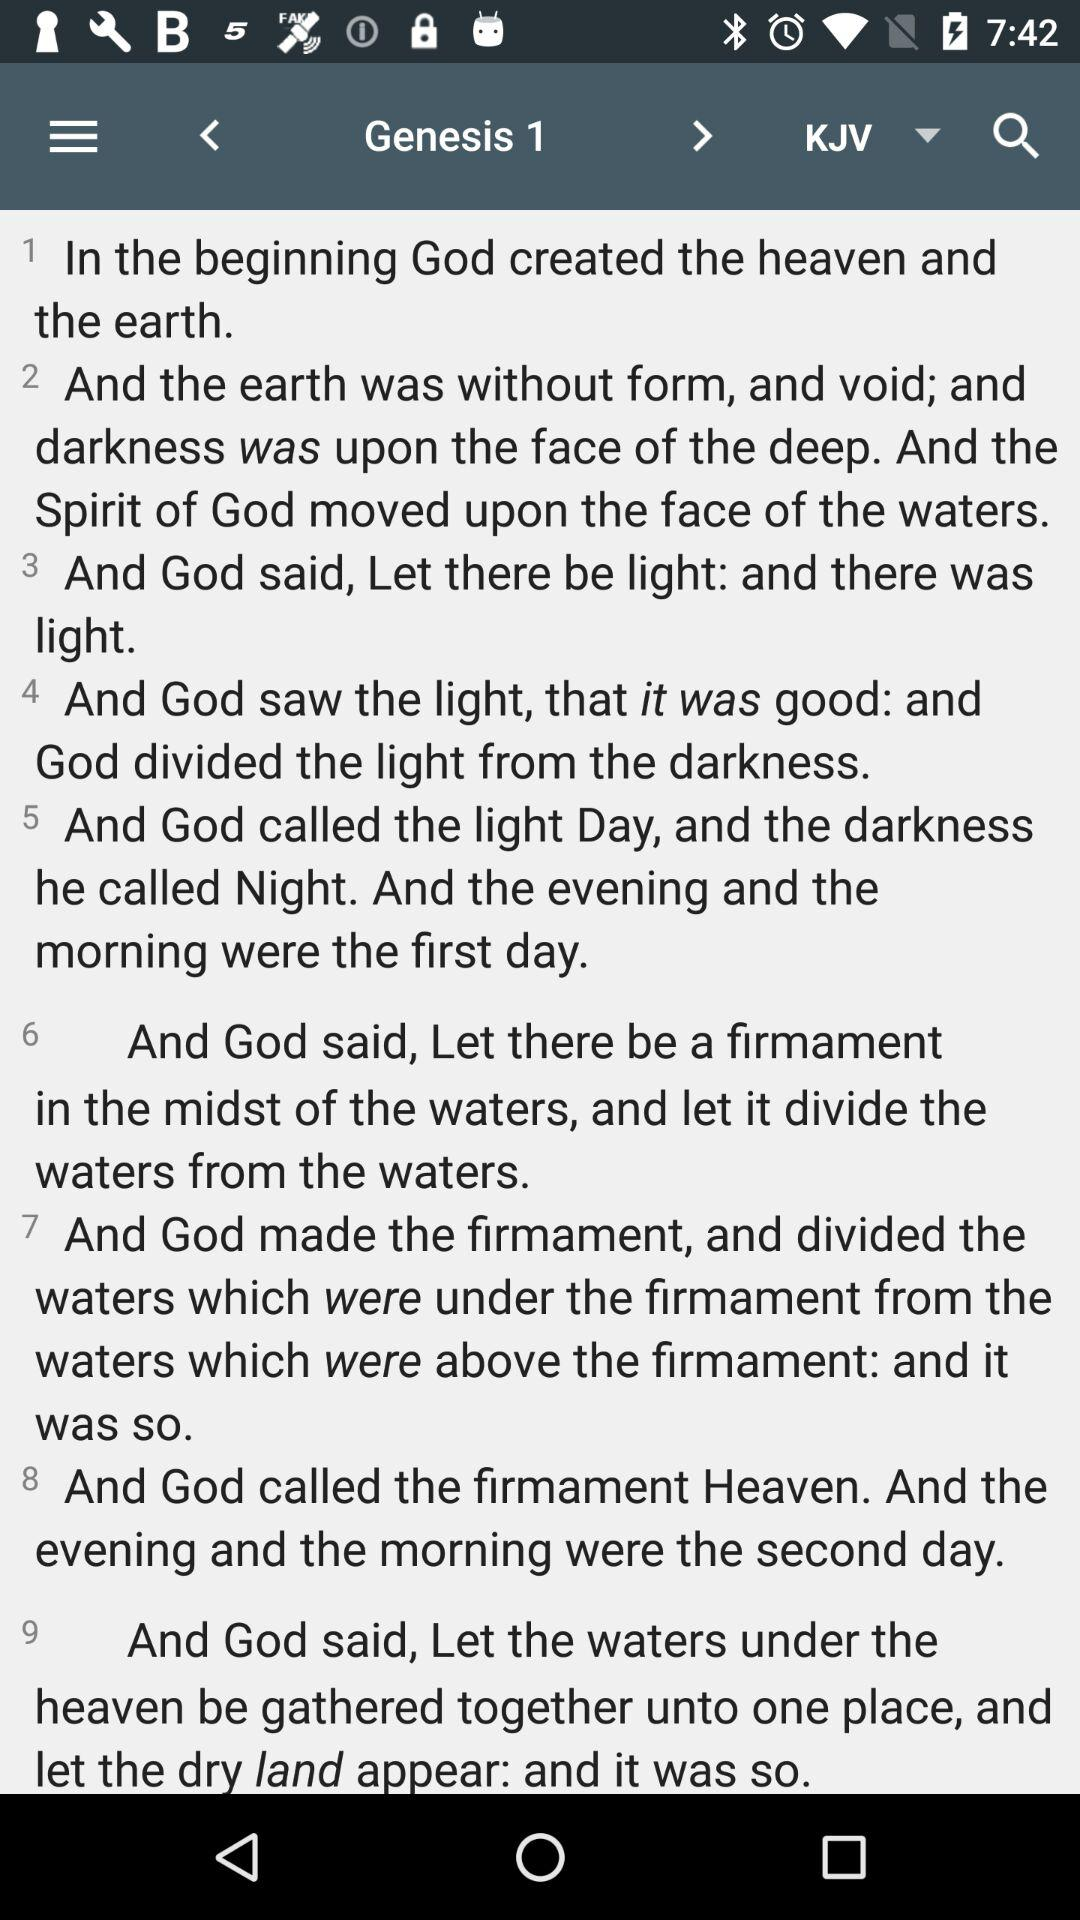How many verses are there in this Bible passage?
Answer the question using a single word or phrase. 9 